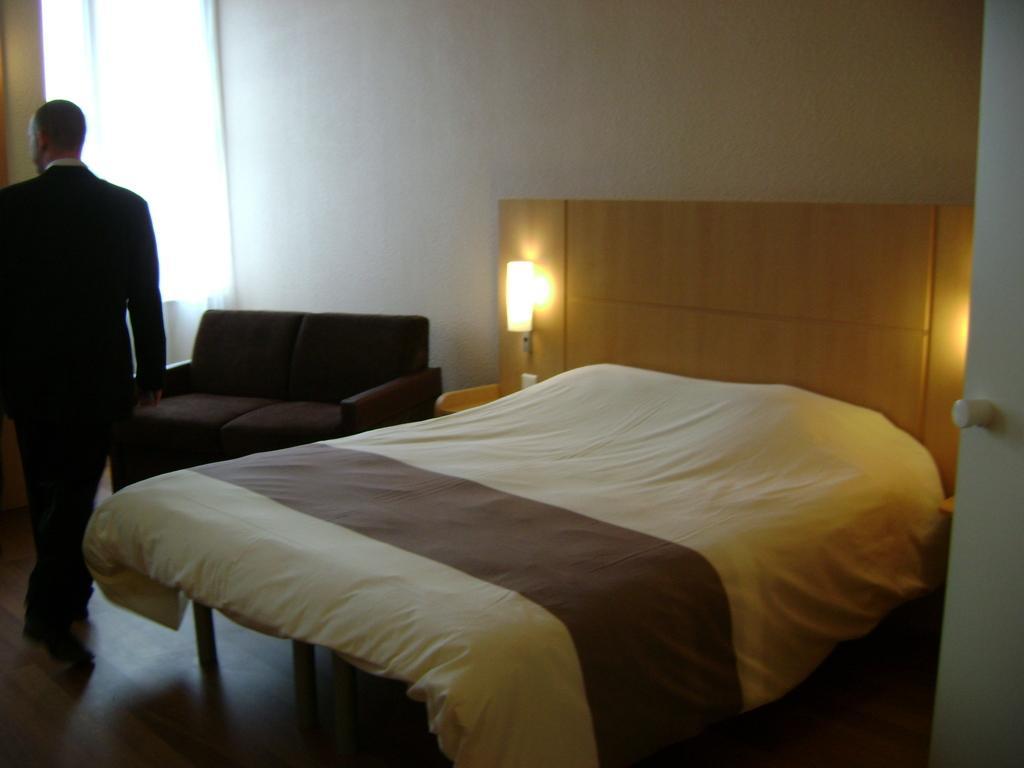Could you give a brief overview of what you see in this image? In the left middle, a person is walking on the floor who is wearing a black suit. The background walls are white in color. At the bottom and middle, bed is there and lamp is there and a sofa brown in color is kept. Next to that a curtain visible white in color. This image is taken inside a room. 